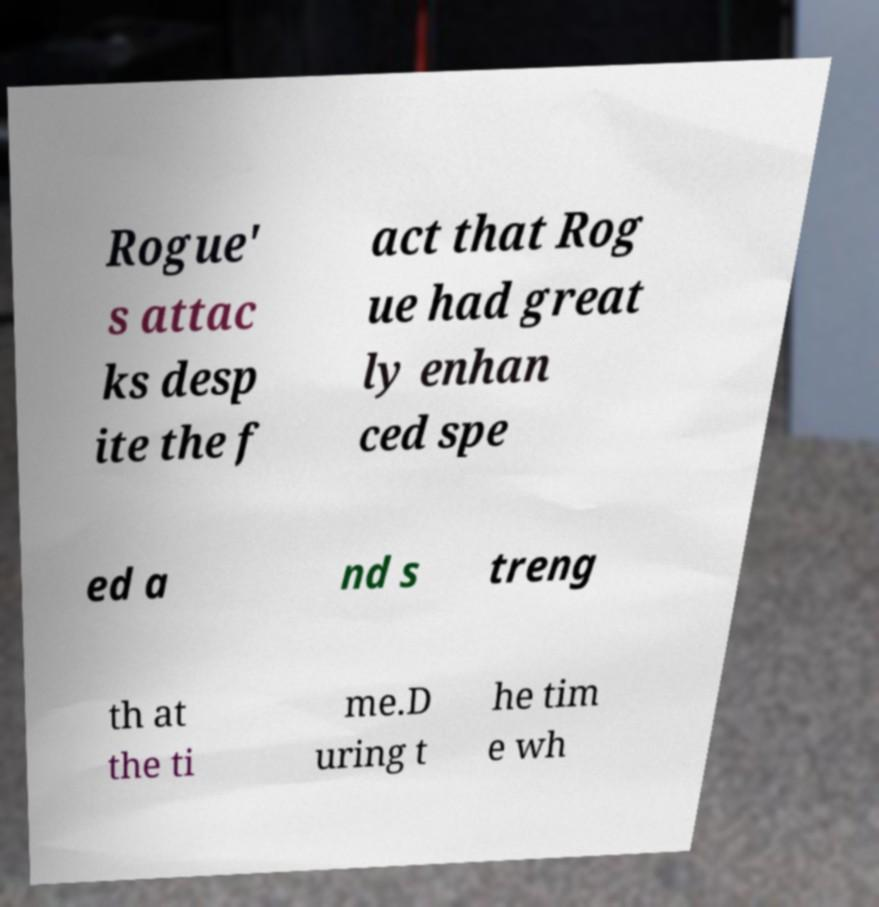What messages or text are displayed in this image? I need them in a readable, typed format. Rogue' s attac ks desp ite the f act that Rog ue had great ly enhan ced spe ed a nd s treng th at the ti me.D uring t he tim e wh 